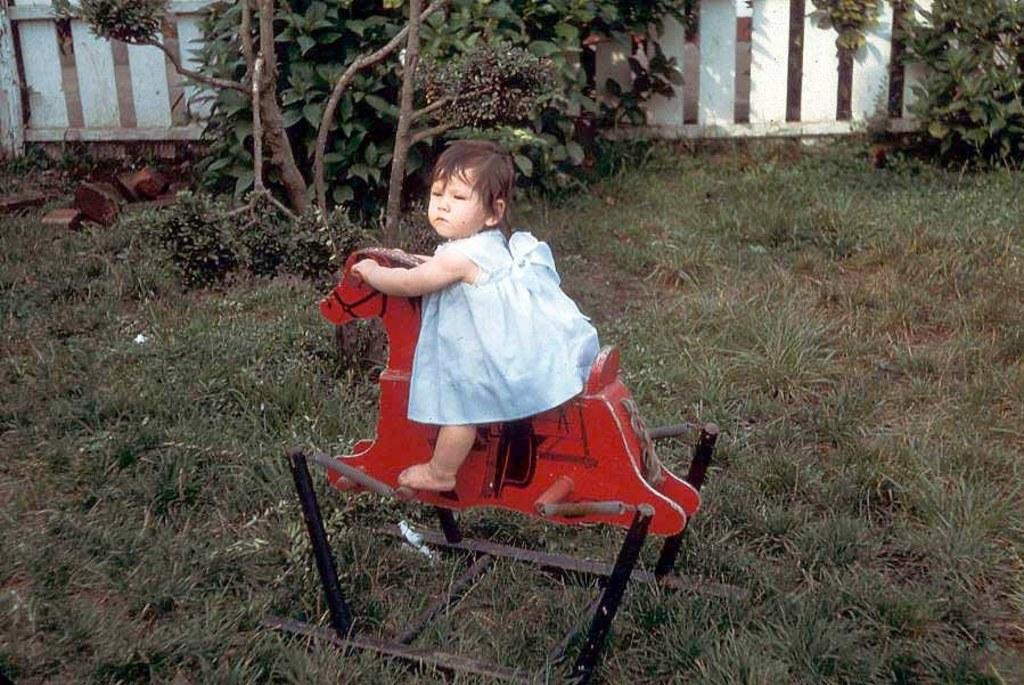Who is the main subject in the image? There is a baby girl in the image. What is the baby girl doing in the image? The baby girl is sitting on a toy horse. What can be seen in the background of the image? There are trees and a wooden fence in the background of the image. What type of surface is the baby girl sitting on? There is grass on the ground in the image. Can you see a rock garden in the image? There is no rock garden present in the image. Is there a cat playing with the baby girl in the image? There is no cat present in the image. 